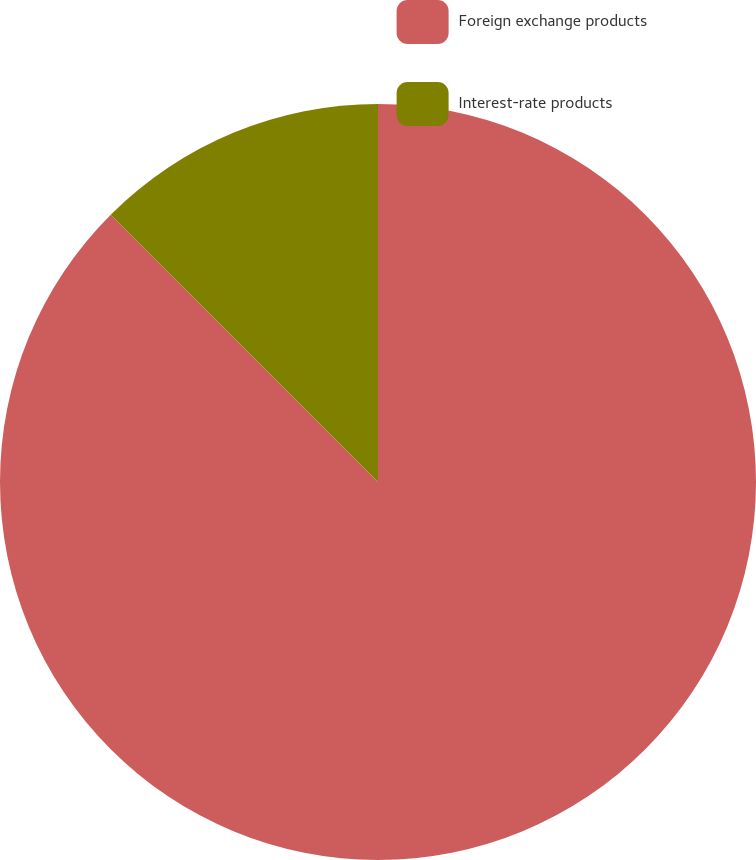Convert chart to OTSL. <chart><loc_0><loc_0><loc_500><loc_500><pie_chart><fcel>Foreign exchange products<fcel>Interest-rate products<nl><fcel>87.5%<fcel>12.5%<nl></chart> 